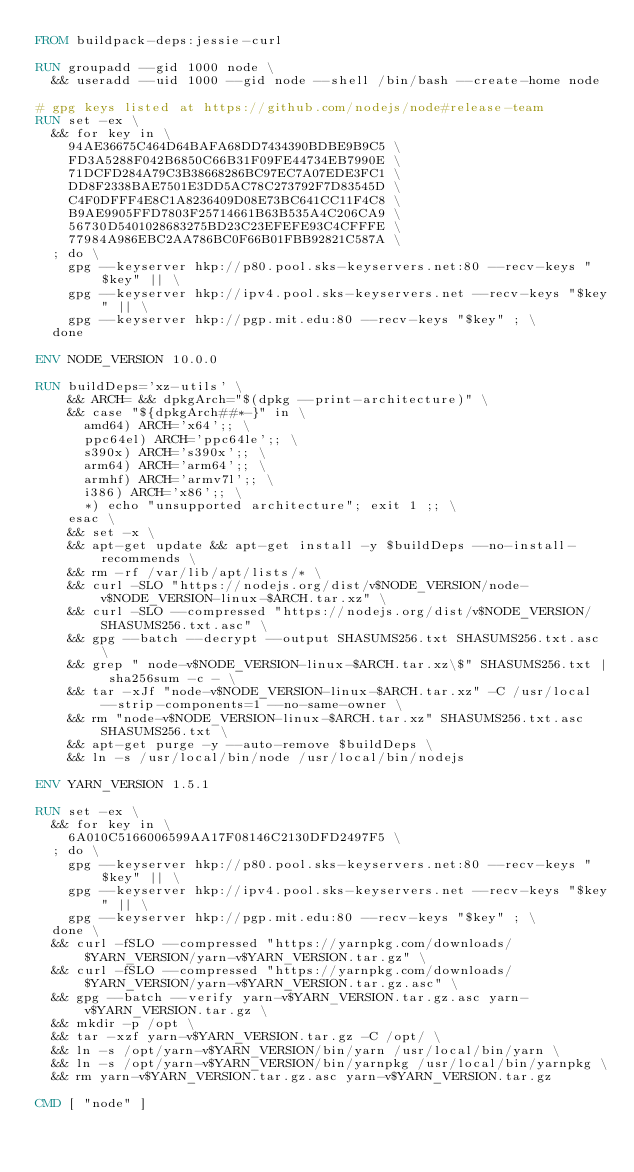<code> <loc_0><loc_0><loc_500><loc_500><_Dockerfile_>FROM buildpack-deps:jessie-curl

RUN groupadd --gid 1000 node \
  && useradd --uid 1000 --gid node --shell /bin/bash --create-home node

# gpg keys listed at https://github.com/nodejs/node#release-team
RUN set -ex \
  && for key in \
    94AE36675C464D64BAFA68DD7434390BDBE9B9C5 \
    FD3A5288F042B6850C66B31F09FE44734EB7990E \
    71DCFD284A79C3B38668286BC97EC7A07EDE3FC1 \
    DD8F2338BAE7501E3DD5AC78C273792F7D83545D \
    C4F0DFFF4E8C1A8236409D08E73BC641CC11F4C8 \
    B9AE9905FFD7803F25714661B63B535A4C206CA9 \
    56730D5401028683275BD23C23EFEFE93C4CFFFE \
    77984A986EBC2AA786BC0F66B01FBB92821C587A \
  ; do \
    gpg --keyserver hkp://p80.pool.sks-keyservers.net:80 --recv-keys "$key" || \
    gpg --keyserver hkp://ipv4.pool.sks-keyservers.net --recv-keys "$key" || \
    gpg --keyserver hkp://pgp.mit.edu:80 --recv-keys "$key" ; \
  done

ENV NODE_VERSION 10.0.0

RUN buildDeps='xz-utils' \
    && ARCH= && dpkgArch="$(dpkg --print-architecture)" \
    && case "${dpkgArch##*-}" in \
      amd64) ARCH='x64';; \
      ppc64el) ARCH='ppc64le';; \
      s390x) ARCH='s390x';; \
      arm64) ARCH='arm64';; \
      armhf) ARCH='armv7l';; \
      i386) ARCH='x86';; \
      *) echo "unsupported architecture"; exit 1 ;; \
    esac \
    && set -x \
    && apt-get update && apt-get install -y $buildDeps --no-install-recommends \
    && rm -rf /var/lib/apt/lists/* \
    && curl -SLO "https://nodejs.org/dist/v$NODE_VERSION/node-v$NODE_VERSION-linux-$ARCH.tar.xz" \
    && curl -SLO --compressed "https://nodejs.org/dist/v$NODE_VERSION/SHASUMS256.txt.asc" \
    && gpg --batch --decrypt --output SHASUMS256.txt SHASUMS256.txt.asc \
    && grep " node-v$NODE_VERSION-linux-$ARCH.tar.xz\$" SHASUMS256.txt | sha256sum -c - \
    && tar -xJf "node-v$NODE_VERSION-linux-$ARCH.tar.xz" -C /usr/local --strip-components=1 --no-same-owner \
    && rm "node-v$NODE_VERSION-linux-$ARCH.tar.xz" SHASUMS256.txt.asc SHASUMS256.txt \
    && apt-get purge -y --auto-remove $buildDeps \
    && ln -s /usr/local/bin/node /usr/local/bin/nodejs

ENV YARN_VERSION 1.5.1

RUN set -ex \
  && for key in \
    6A010C5166006599AA17F08146C2130DFD2497F5 \
  ; do \
    gpg --keyserver hkp://p80.pool.sks-keyservers.net:80 --recv-keys "$key" || \
    gpg --keyserver hkp://ipv4.pool.sks-keyservers.net --recv-keys "$key" || \
    gpg --keyserver hkp://pgp.mit.edu:80 --recv-keys "$key" ; \
  done \
  && curl -fSLO --compressed "https://yarnpkg.com/downloads/$YARN_VERSION/yarn-v$YARN_VERSION.tar.gz" \
  && curl -fSLO --compressed "https://yarnpkg.com/downloads/$YARN_VERSION/yarn-v$YARN_VERSION.tar.gz.asc" \
  && gpg --batch --verify yarn-v$YARN_VERSION.tar.gz.asc yarn-v$YARN_VERSION.tar.gz \
  && mkdir -p /opt \
  && tar -xzf yarn-v$YARN_VERSION.tar.gz -C /opt/ \
  && ln -s /opt/yarn-v$YARN_VERSION/bin/yarn /usr/local/bin/yarn \
  && ln -s /opt/yarn-v$YARN_VERSION/bin/yarnpkg /usr/local/bin/yarnpkg \
  && rm yarn-v$YARN_VERSION.tar.gz.asc yarn-v$YARN_VERSION.tar.gz

CMD [ "node" ]
</code> 